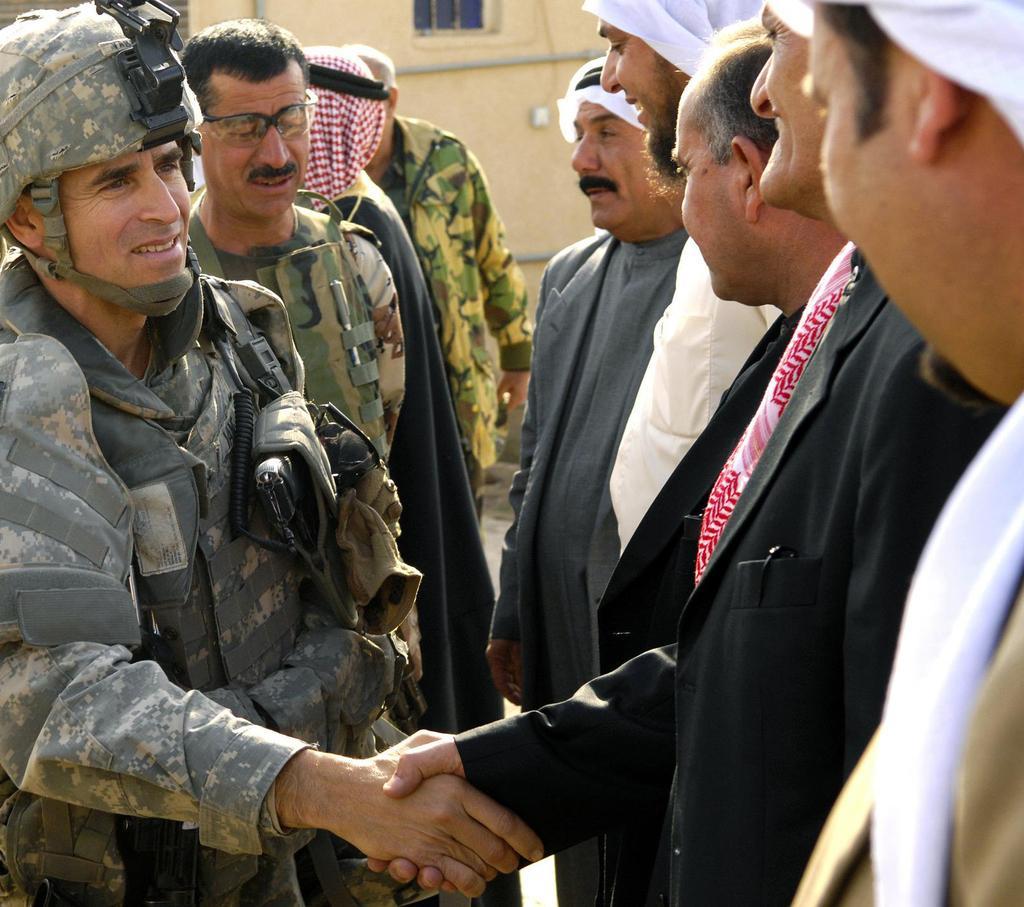Describe this image in one or two sentences. In this image, we can see some people standing, we can see two men shaking hands, in the background we can see a wall and a window. 